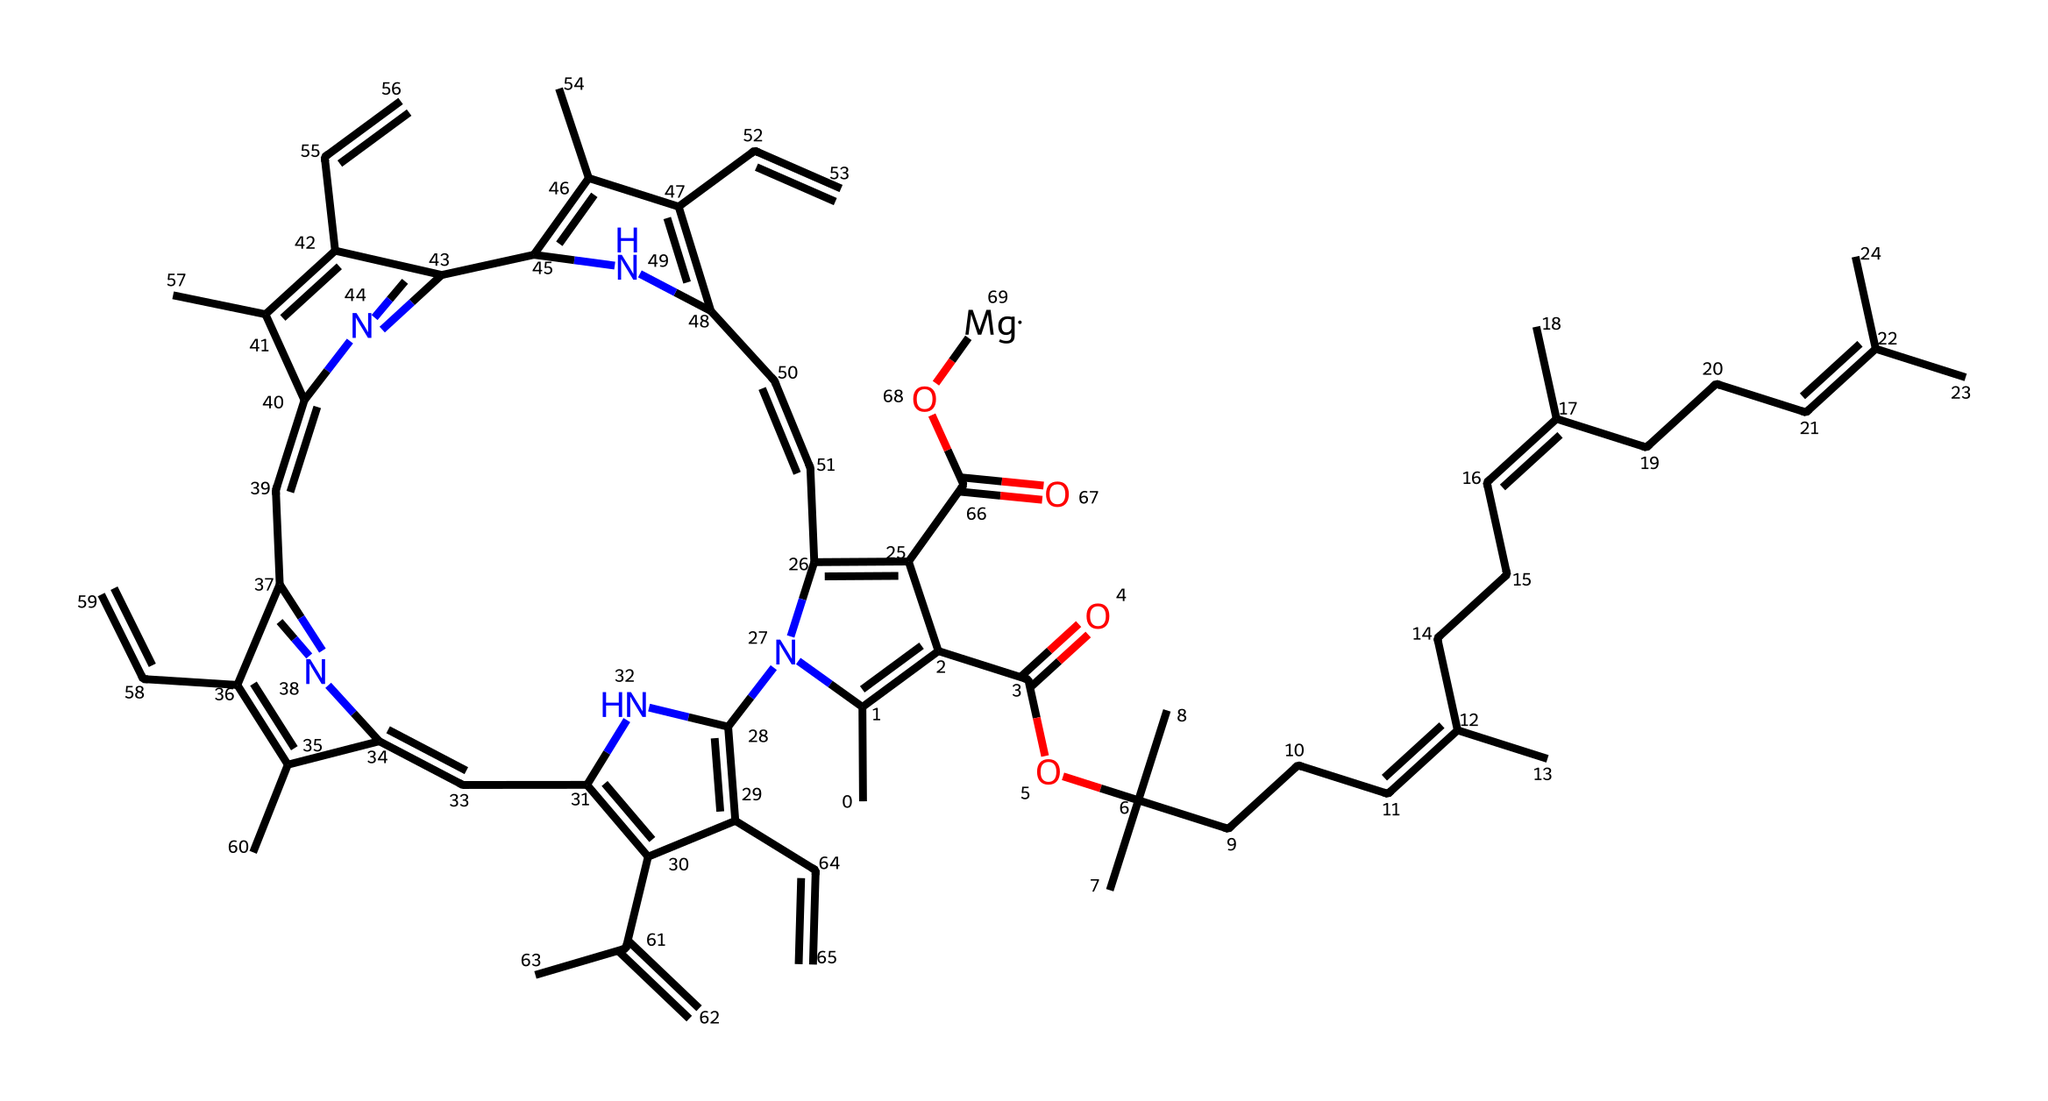How many rings are in this chlorophyll structure? By analyzing the SMILES representation, we can identify the number of ring systems present. The "C" and "N" characters grouped with parentheses indicate ring formations. Count the distinct sets of parentheses that are closed to reveal the number of rings, which totals to four comprehensive ring systems.
Answer: four What is the primary metal present in chlorophyll? The formation of this chemical structure indicates it has a central metal atom. Specifically, the presence of "[Mg]" at the end of the SMILES string signifies that magnesium is the primary metal present, which is essential for the chlorophyll structure's function in photosynthesis.
Answer: magnesium What functional group is indicated by “C(=O)O” in this chlorophyll structure? The notation "C(=O)O" denotes a carboxyl functional group; the "C(=O)" shows a carbonyl (C=O) that is directly attached to an -OH group, classifying it as a carboxylic acid, which plays a role in the biochemical properties of chlorophyll.
Answer: carboxyl What type of reaction products can chlorophyll facilitate? Given chlorophyll's roles in photosynthesis, particularly its absorption of light and conversion of carbon dioxide and water to glucose and oxygen, it is primarily involved in photosynthetic reaction products, indicating it likely facilitates the formation of sugars and oxygen through light-induced reactions.
Answer: sugars and oxygen How many nitrogen atoms are present in this chlorophyll structure? By closely examining the SMILES notation, we can locate the nitrogen atoms indicated by 'N’ characters in the structure. Counting these reveals a total of five nitrogen atoms present in the entire chlorophyll molecule, as seen in various positions throughout the structure.
Answer: five What characteristic of chlorophyll allows it to absorb light? The arrangement of double bonds in conjugated systems throughout the chlorophyll's extensive ring structures allows for delocalization of electrons. This electron delocalization enables the molecule to absorb photons effectively, making chlorophyll particularly efficient in capturing light energy.
Answer: conjugated double bonds 